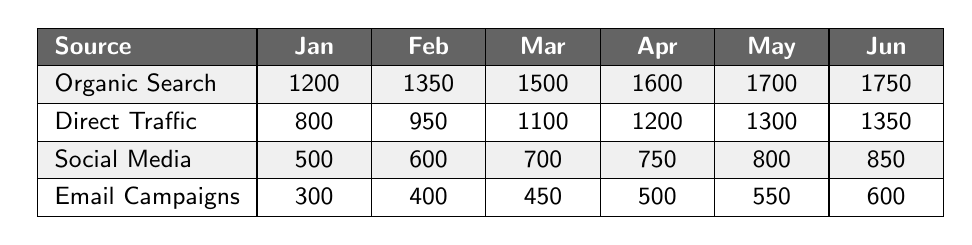What was the total number of visits from Organic Search in March and April 2023? The visits from Organic Search in March 2023 was 1500 and in April 2023 was 1600. Summing these gives 1500 + 1600 = 3100.
Answer: 3100 Which month saw the highest visits from Direct Traffic? The table shows that visits from Direct Traffic were 1350 in June 2023, which is the highest among all months listed.
Answer: June 2023 What is the percentage increase in visits from Social Media from January to June 2023? Social Media visits increased from 500 in January to 850 in June. The increase is 850 - 500 = 350. The percentage increase is (350 / 500) * 100 = 70%.
Answer: 70% Did Email Campaigns receive more visits than Social Media in May 2023? In May 2023, Email Campaigns received 550 visits, while Social Media received 800 visits. This shows that Email Campaigns had fewer visits than Social Media.
Answer: No What is the average number of visits from all sources in February 2023? For February 2023, the visits are: Organic Search (1350), Direct Traffic (950), Social Media (600), and Email Campaigns (400). Adding these gives 1350 + 950 + 600 + 400 = 3350, and the average is 3350 / 4 = 837.5.
Answer: 837.5 Which source had the highest cumulative visits from January to June 2023? Summing visits for each source from January to June, Organic Search totals 9600, Direct Traffic totals 8800, Social Media totals 4150, and Email Campaigns totals 2800. Organic Search has the highest cumulative visits at 9600.
Answer: Organic Search What was the difference in visits from Email Campaigns between January and April 2023? The visits from Email Campaigns in January 2023 were 300, and in April 2023 they were 500. The difference is 500 - 300 = 200.
Answer: 200 In which month did Social Media have the smallest total visits? Looking at the table, Social Media visits were 500 in January 2023, which is the smallest number recorded for that source in all months.
Answer: January 2023 What was the cumulative growth in visits from Direct Traffic from January to May 2023? The visits for Direct Traffic were 800 in January and increased to 1300 in May. The difference is 1300 - 800 = 500. Thus, the cumulative growth is 500 visits.
Answer: 500 Is it true that visits from Organic Search consistently increased every month? By examining the values, Organic Search visits increased from 1200 in January to 1750 in June without any decrease at any point.
Answer: Yes 